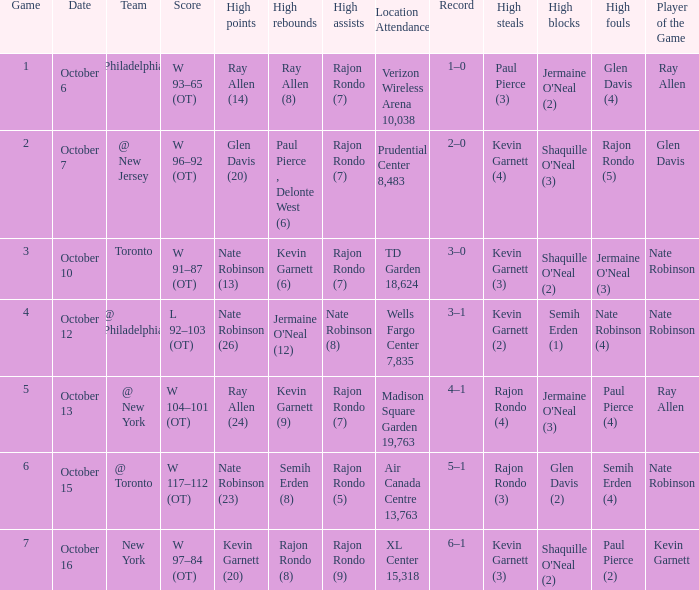Who had the most assists and how many did they have on October 7?  Rajon Rondo (7). Would you be able to parse every entry in this table? {'header': ['Game', 'Date', 'Team', 'Score', 'High points', 'High rebounds', 'High assists', 'Location Attendance', 'Record', 'High steals', 'High blocks', 'High fouls', 'Player of the Game'], 'rows': [['1', 'October 6', 'Philadelphia', 'W 93–65 (OT)', 'Ray Allen (14)', 'Ray Allen (8)', 'Rajon Rondo (7)', 'Verizon Wireless Arena 10,038', '1–0', 'Paul Pierce (3)', "Jermaine O'Neal (2)", 'Glen Davis (4)', 'Ray Allen'], ['2', 'October 7', '@ New Jersey', 'W 96–92 (OT)', 'Glen Davis (20)', 'Paul Pierce , Delonte West (6)', 'Rajon Rondo (7)', 'Prudential Center 8,483', '2–0', 'Kevin Garnett (4)', "Shaquille O'Neal (3)", 'Rajon Rondo (5)', 'Glen Davis '], ['3', 'October 10', 'Toronto', 'W 91–87 (OT)', 'Nate Robinson (13)', 'Kevin Garnett (6)', 'Rajon Rondo (7)', 'TD Garden 18,624', '3–0', 'Kevin Garnett (3)', "Shaquille O'Neal (2)", "Jermaine O'Neal (3)", 'Nate Robinson'], ['4', 'October 12', '@ Philadelphia', 'L 92–103 (OT)', 'Nate Robinson (26)', "Jermaine O'Neal (12)", 'Nate Robinson (8)', 'Wells Fargo Center 7,835', '3–1', 'Kevin Garnett (2)', 'Semih Erden (1)', 'Nate Robinson (4)', 'Nate Robinson'], ['5', 'October 13', '@ New York', 'W 104–101 (OT)', 'Ray Allen (24)', 'Kevin Garnett (9)', 'Rajon Rondo (7)', 'Madison Square Garden 19,763', '4–1', 'Rajon Rondo (4)', "Jermaine O'Neal (3)", 'Paul Pierce (4)', 'Ray Allen '], ['6', 'October 15', '@ Toronto', 'W 117–112 (OT)', 'Nate Robinson (23)', 'Semih Erden (8)', 'Rajon Rondo (5)', 'Air Canada Centre 13,763', '5–1', 'Rajon Rondo (3)', 'Glen Davis (2)', 'Semih Erden (4)', 'Nate Robinson '], ['7', 'October 16', 'New York', 'W 97–84 (OT)', 'Kevin Garnett (20)', 'Rajon Rondo (8)', 'Rajon Rondo (9)', 'XL Center 15,318', '6–1', 'Kevin Garnett (3)', "Shaquille O'Neal (2)", 'Paul Pierce (2)', 'Kevin Garnett']]} 